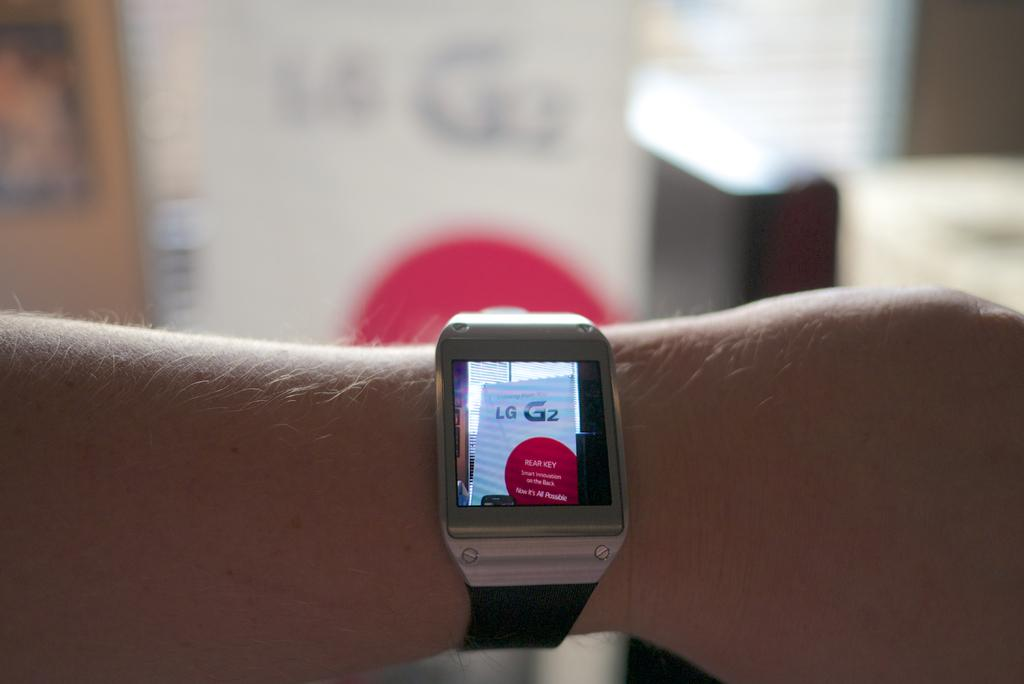What is the person's hand holding in the image? The person's hand is holding a wrist watch. What is the wrist watch doing in the image? The wrist watch is displaying an image. What else can be seen in the background of the image? There are other objects in the background of the image. How many pins are attached to the dolls in the image? There are no dolls or pins present in the image. 